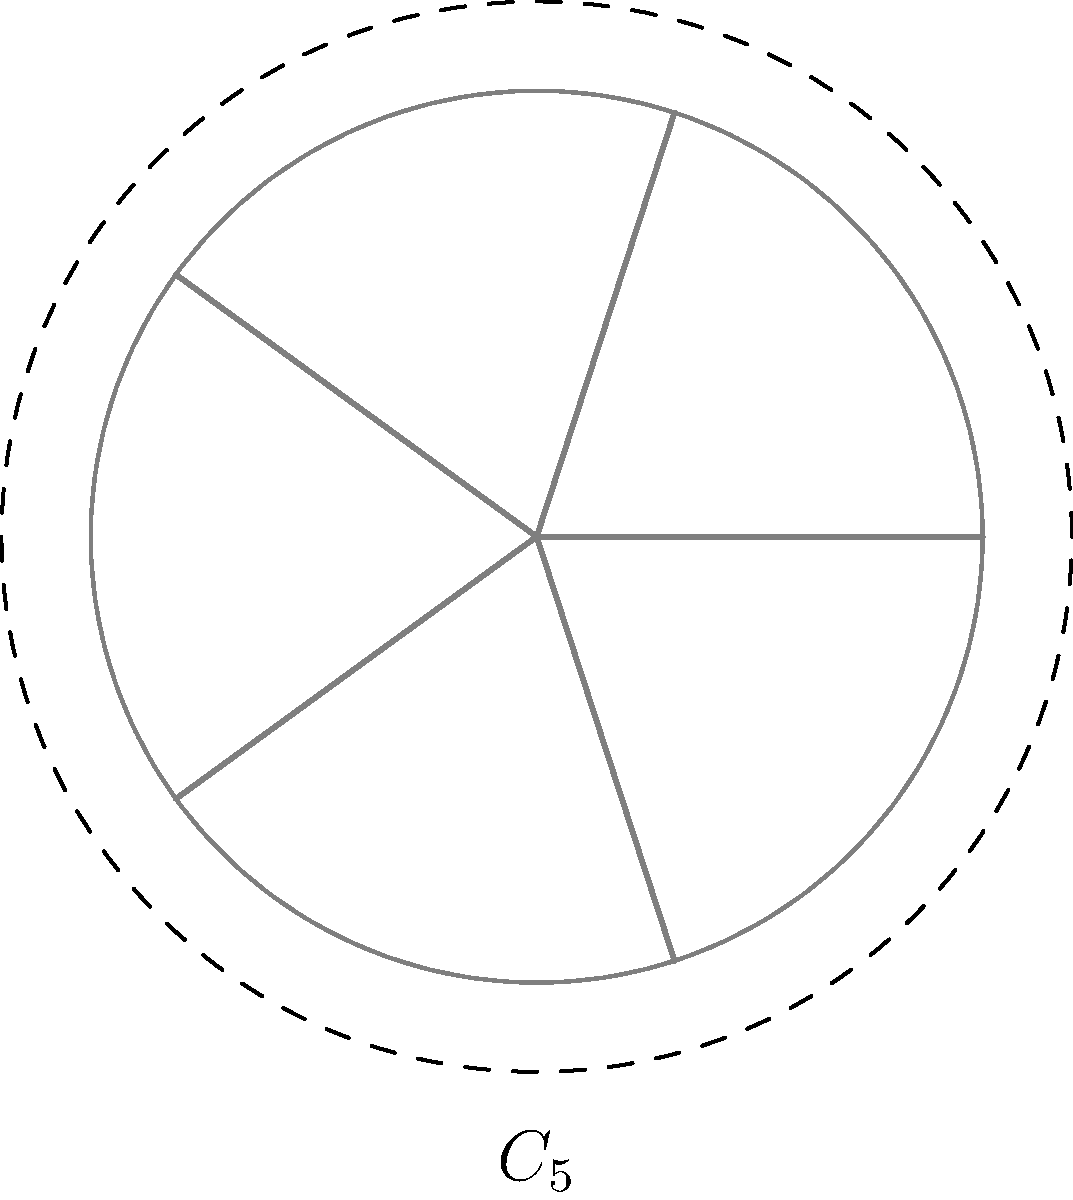Your ceiling fan has seen better days, with one of its five blades slightly bent. Despite this imperfection, you notice it still maintains a certain symmetry when rotating. If the group of rotational symmetries of this weathered fan is isomorphic to the cyclic group $C_5$, what is the order of the smallest non-identity rotation that generates this group? Let's approach this step-by-step:

1) The group of rotational symmetries isomorphic to $C_5$ implies that the fan has 5-fold rotational symmetry.

2) In a cyclic group $C_n$, the smallest non-identity rotation is a rotation by $\frac{360°}{n}$.

3) For our fan with 5-fold symmetry, $n = 5$.

4) Therefore, the smallest non-identity rotation is $\frac{360°}{5} = 72°$.

5) This 72° rotation generates the entire group because:
   - One 72° rotation gives the generator of the group.
   - Two 72° rotations (144°) give the square of the generator.
   - Three 72° rotations (216°) give the cube of the generator.
   - Four 72° rotations (288°) give the fourth power of the generator.
   - Five 72° rotations (360° or 0°) give the identity element.

6) The order of an element in a group is the smallest positive integer $k$ such that $a^k = e$, where $e$ is the identity element.

7) In this case, it takes 5 applications of the 72° rotation to return to the starting position (identity).

Therefore, the order of the 72° rotation is 5.
Answer: 5 